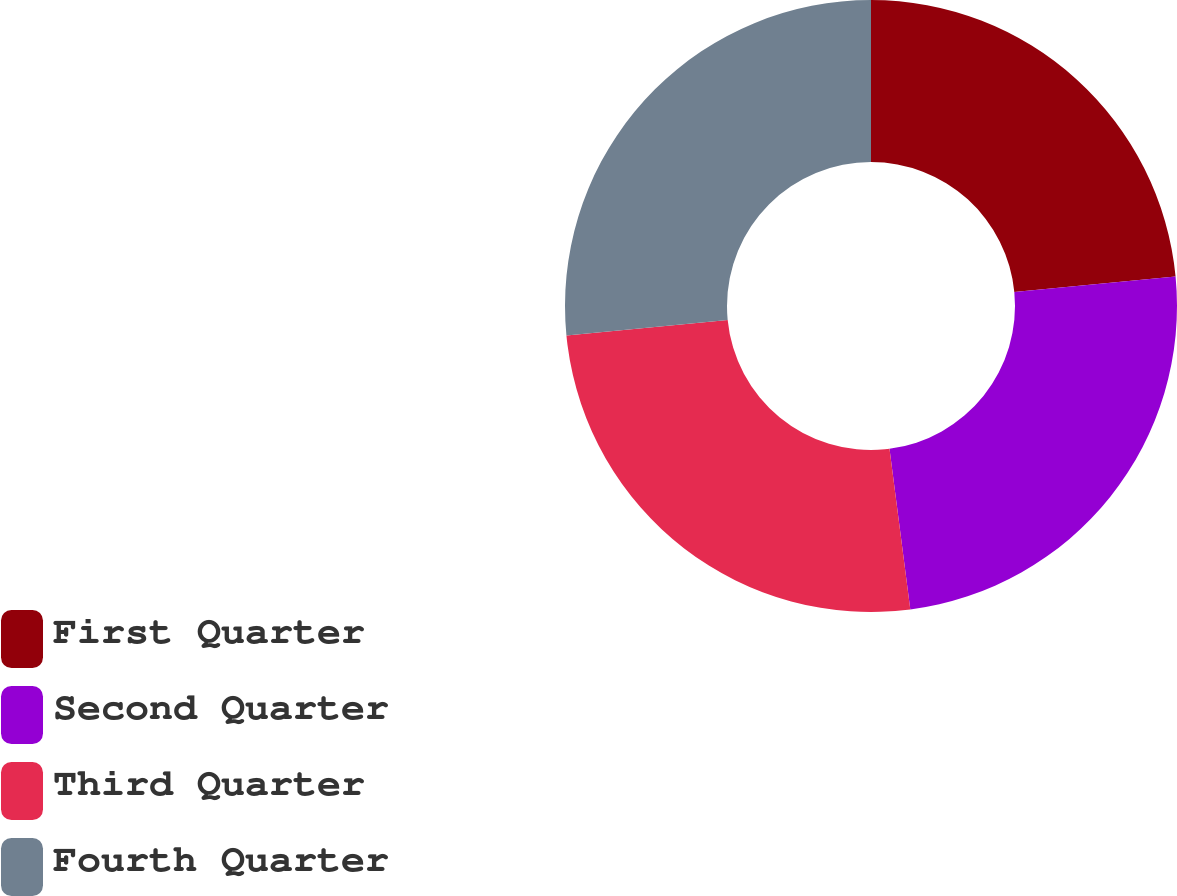<chart> <loc_0><loc_0><loc_500><loc_500><pie_chart><fcel>First Quarter<fcel>Second Quarter<fcel>Third Quarter<fcel>Fourth Quarter<nl><fcel>23.46%<fcel>24.49%<fcel>25.51%<fcel>26.54%<nl></chart> 